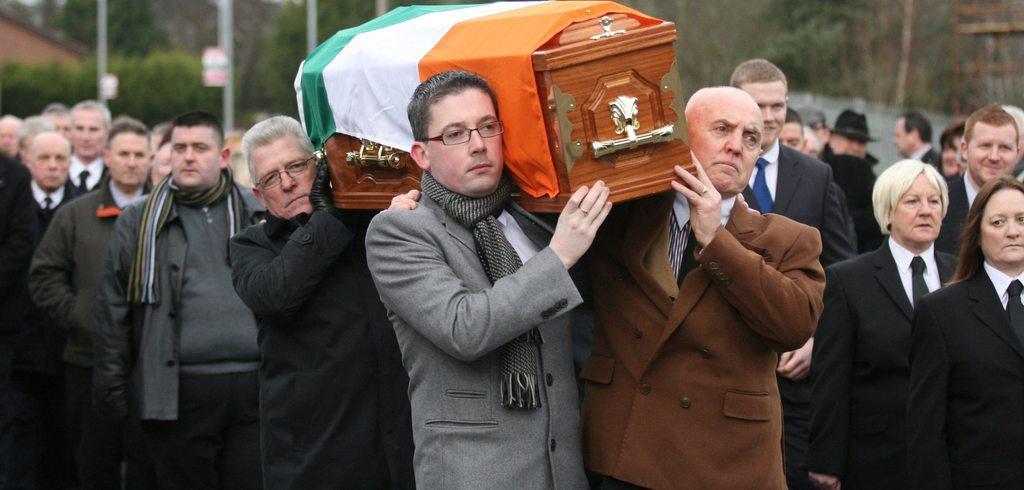Please provide a concise description of this image. In the picture I can see a group of people are standing, among them the people in the front are carrying a coffin which is covered with a flag on it. The background of the image is blurred. 